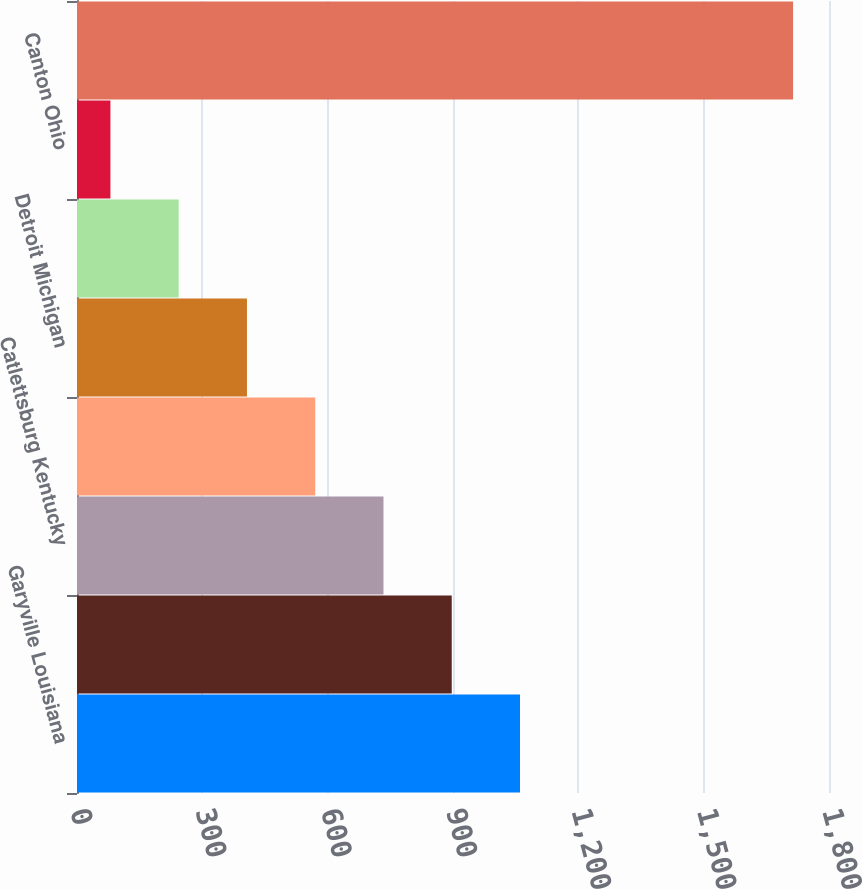Convert chart. <chart><loc_0><loc_0><loc_500><loc_500><bar_chart><fcel>Garyville Louisiana<fcel>Galveston Bay Texas City Texas<fcel>Catlettsburg Kentucky<fcel>Robinson Illinois<fcel>Detroit Michigan<fcel>Texas City Texas<fcel>Canton Ohio<fcel>Total<nl><fcel>1060.4<fcel>897<fcel>733.6<fcel>570.2<fcel>406.8<fcel>243.4<fcel>80<fcel>1714<nl></chart> 